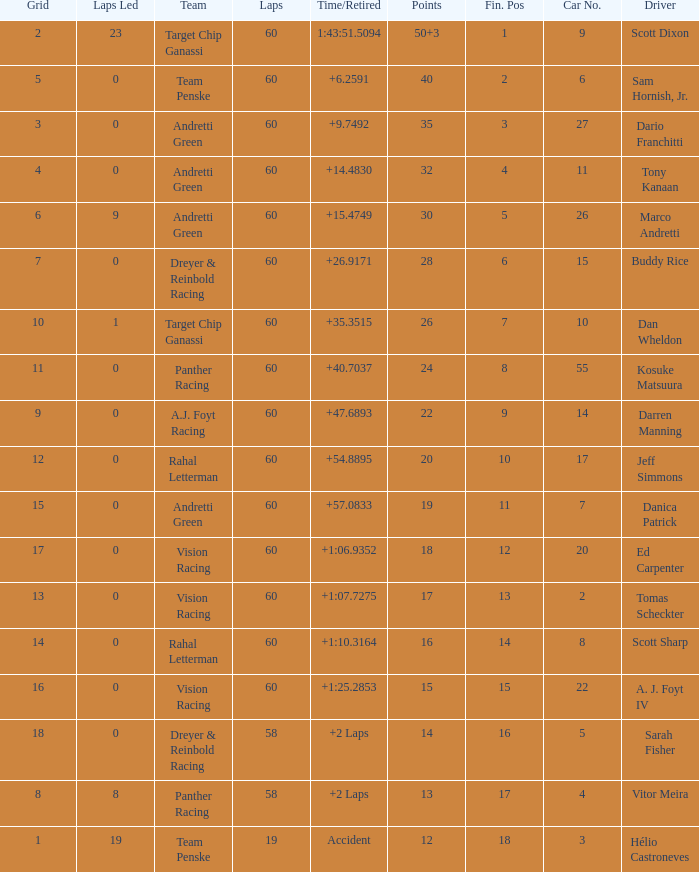Name the laps for 18 pointss 60.0. 